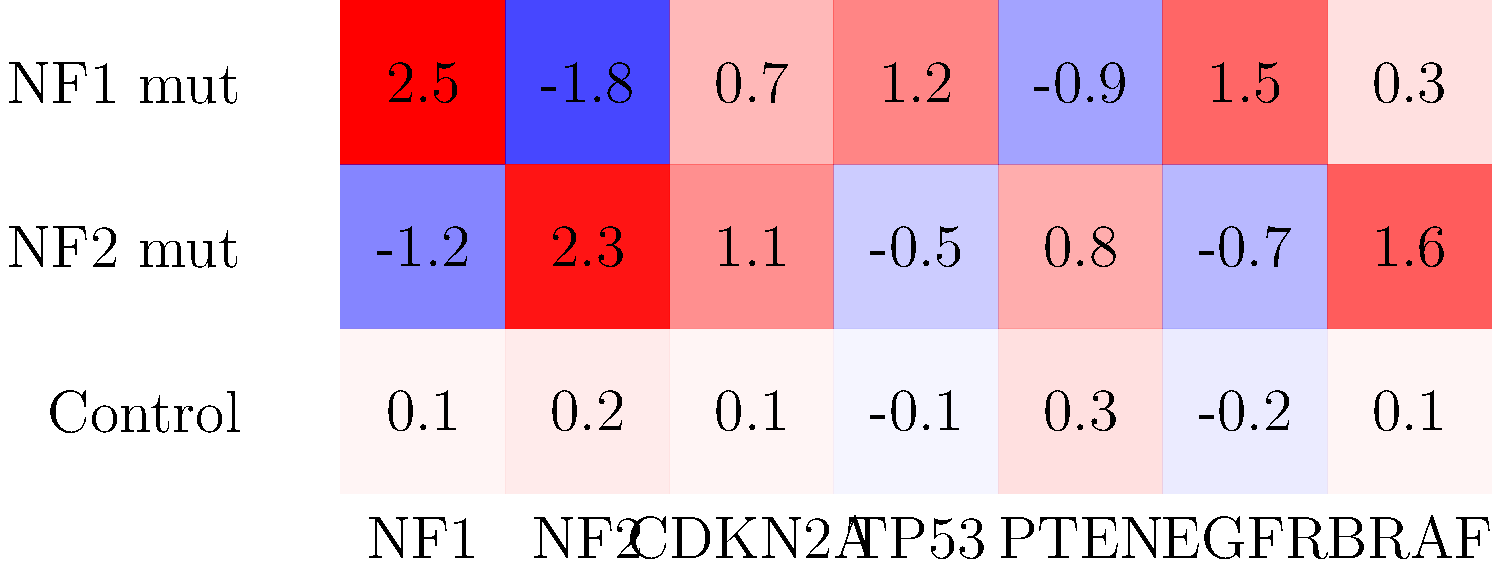Based on the gene expression heat map provided, which of the following statements is most accurate regarding the expression patterns of NF1 and NF2 in relation to their respective mutations? To answer this question, we need to analyze the gene expression patterns in the heat map for NF1 and NF2 genes across the different sample types:

1. First, look at the NF1 gene (first column):
   - In NF1 mutant samples: Expression value is 2.5 (high upregulation)
   - In NF2 mutant samples: Expression value is -1.2 (moderate downregulation)
   - In Control samples: Expression value is 0.1 (near normal)

2. Now, examine the NF2 gene (second column):
   - In NF1 mutant samples: Expression value is -1.8 (moderate downregulation)
   - In NF2 mutant samples: Expression value is 2.3 (high upregulation)
   - In Control samples: Expression value is 0.2 (near normal)

3. Analyze the patterns:
   - NF1 is highly upregulated in NF1 mutant samples but downregulated in NF2 mutant samples
   - NF2 is highly upregulated in NF2 mutant samples but downregulated in NF1 mutant samples
   - Both genes show near-normal expression in control samples

4. Interpret the results:
   - The data suggests a reciprocal relationship between NF1 and NF2 mutations and their gene expression
   - Each mutation leads to upregulation of its corresponding gene and downregulation of the other gene

5. Conclusion:
   The most accurate statement is that NF1 and NF2 mutations lead to upregulation of their respective genes while downregulating the other gene, indicating a potential compensatory mechanism or interrelated pathway between these two tumor suppressor genes.
Answer: NF1 and NF2 mutations upregulate their respective genes while downregulating the other. 